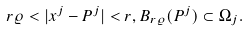<formula> <loc_0><loc_0><loc_500><loc_500>r \varrho < | x ^ { j } - P ^ { j } | < r , B _ { r \varrho } ( P ^ { j } ) \subset \Omega _ { j } .</formula> 